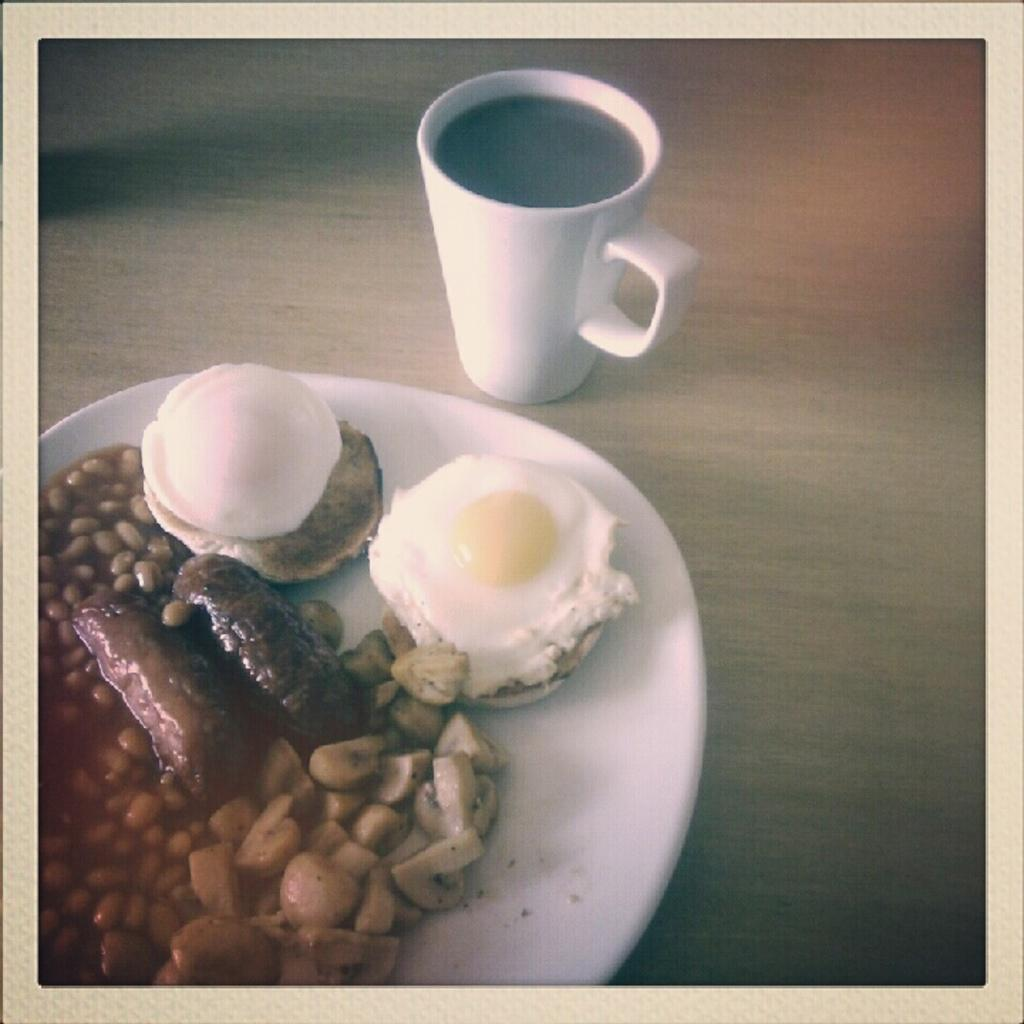What is on the white plate in the image? The plate contains cream, egg yolk, a hot dog, and peanuts. Are there any other food items on the plate? Yes, there are other food items on the plate. What can be seen on the table in the image? There is a teacup on the table in the image. How does the alarm sound in the image? There is no alarm present in the image. What type of bubble is floating above the plate in the image? There are no bubbles present in the image. 